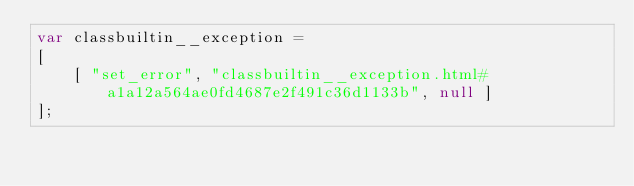Convert code to text. <code><loc_0><loc_0><loc_500><loc_500><_JavaScript_>var classbuiltin__exception =
[
    [ "set_error", "classbuiltin__exception.html#a1a12a564ae0fd4687e2f491c36d1133b", null ]
];</code> 